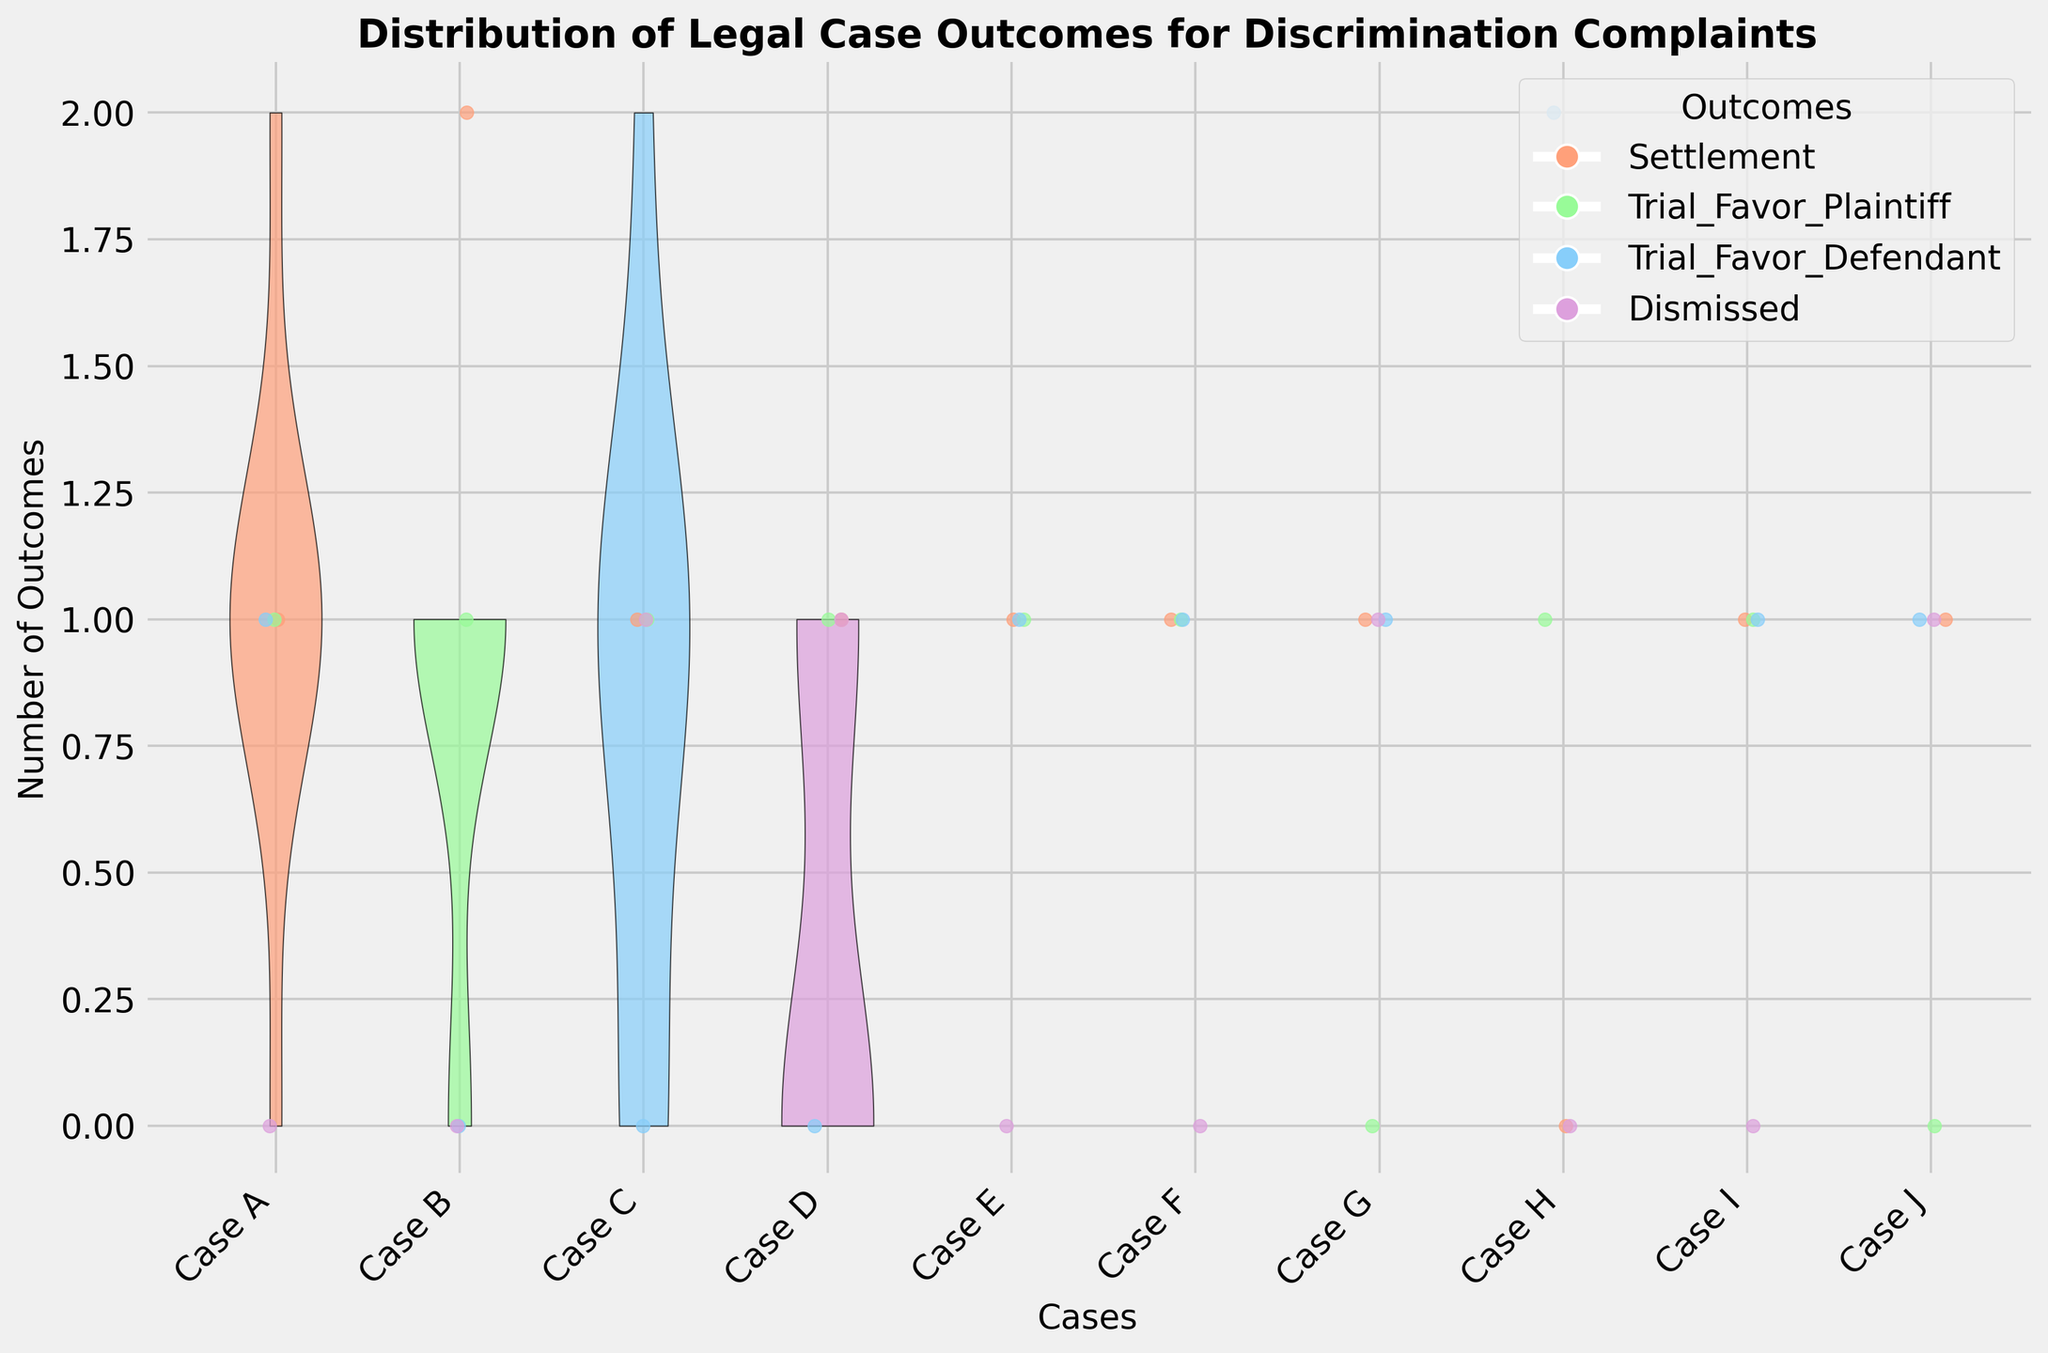What is the title of the plot? The title of the plot is written at the top of the figure and contains key phrases that help identify the purpose of the visualization.
Answer: Distribution of Legal Case Outcomes for Discrimination Complaints How many different outcomes are represented in the plot? There are four distinct segments in the plot, each with a specific color. The legend clearly identifies these segments by listing all possible outcomes.
Answer: Four Which case has the highest number of settlements? Look for the case where the portion of the violin plot corresponding to settlements (marked in a specific color) is highest. Count the number of individual settlement points in that case.
Answer: Case B Which outcome occurs most frequently across all cases? To determine this, observe all portions of the violin plots and count the number of individual outcome points for each category. The category with the highest count is the most frequent.
Answer: Settlement Are there any cases with evenly distributed outcomes? Inspect each case to see whether the different outcomes appear equally (or nearly equally) represented. Look for roughly equal heights in the violin plots and similar scatter of different colors.
Answer: None Which case has the most dismissals? Look for the case where the violin plot section for dismissals is the widest or densest. Count the individual outcome points to confirm.
Answer: Case J How does the number of Trial_Favor_Plaintiff outcomes compare between Case A and Case H? Compare the number of outcome points for Trial_Favor_Plaintiff in Case A to those in Case H by examining the specific sections and scatter points for these cases.
Answer: Same (both have one each) What is the sum of Trial_Favor_Defendant outcomes for all cases? Add up the number of individual points corresponding to Trial_Favor_Defendant across all cases.
Answer: 8 What is the average number of Settlement outcomes per case? Count the total number of Settlement outcomes and divide it by the number of cases (10).
Answer: 1.6 Which case has the widest distribution among all outcomes? Look for the case with the most spread or width in its entire violin plot, indicating a larger variance in outcome counts.
Answer: Case H 